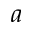Convert formula to latex. <formula><loc_0><loc_0><loc_500><loc_500>a</formula> 